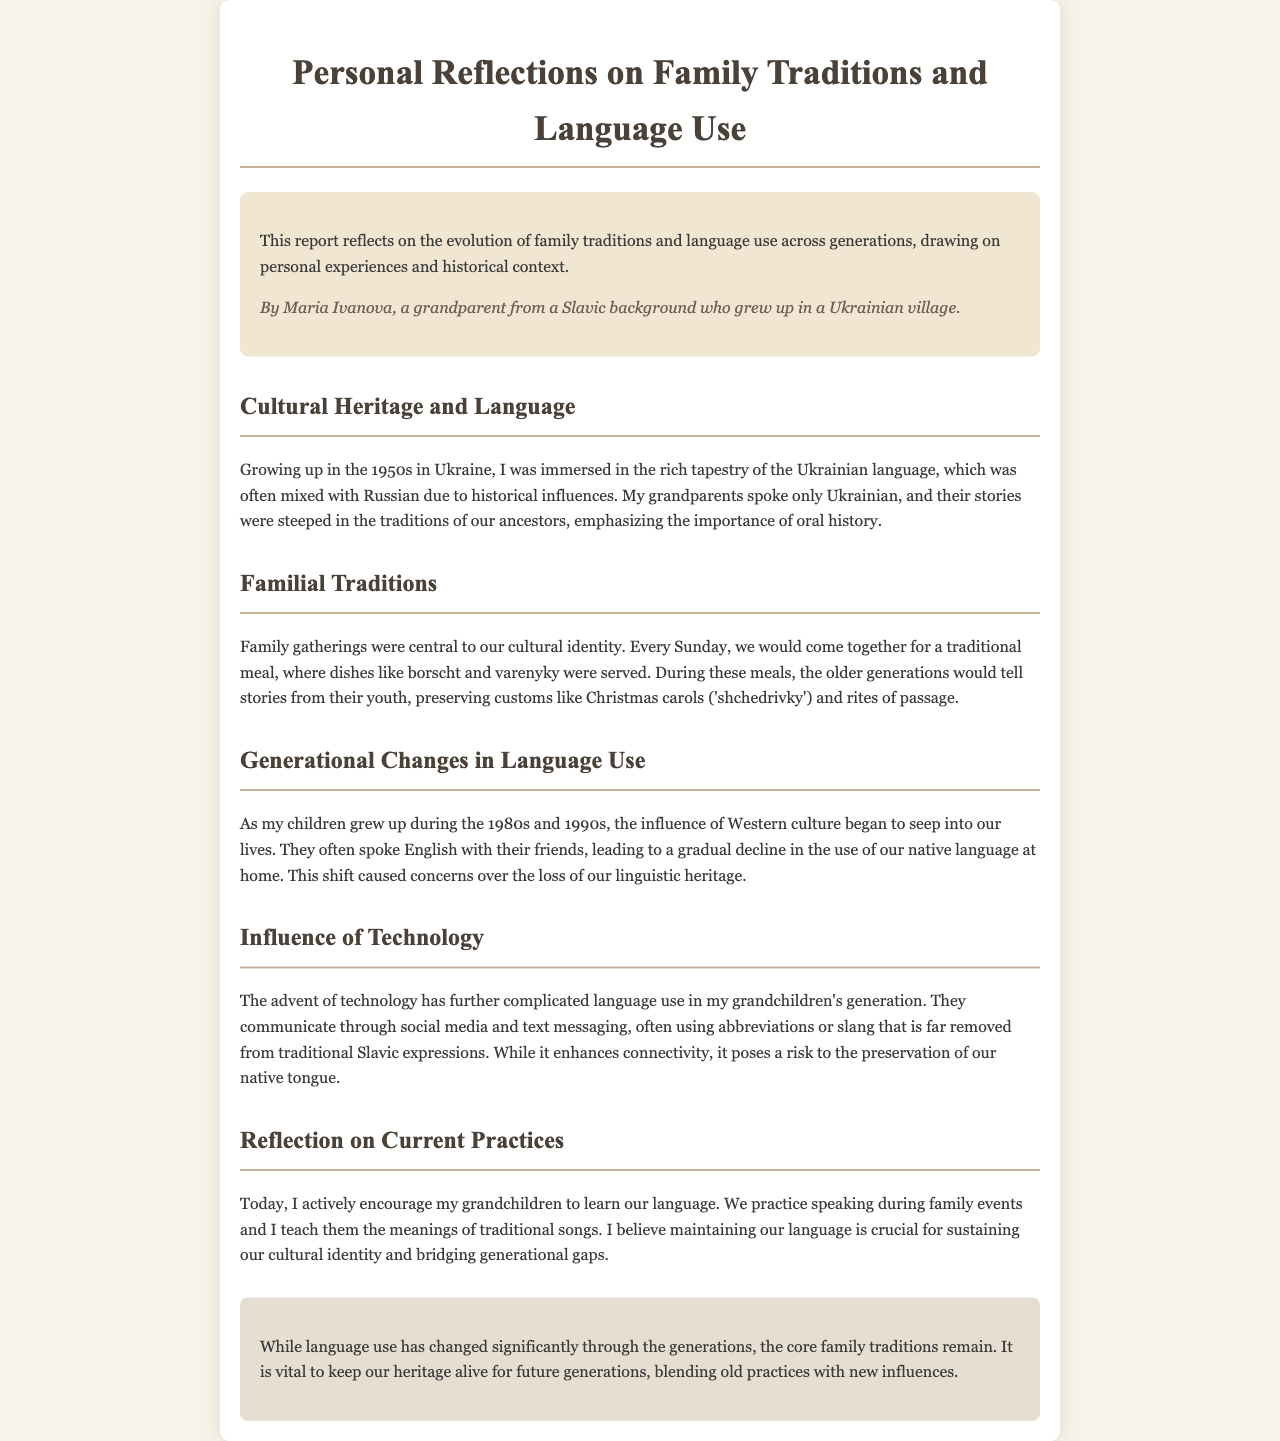What decade did the author grow up in? The author mentions growing up in the 1950s in Ukraine, indicating the decade.
Answer: 1950s What traditional dish is mentioned in family gatherings? The document mentions borscht as a traditional dish served during family gatherings.
Answer: borscht What language did the author's grandparents speak? The report states that the author's grandparents spoke only Ukrainian.
Answer: Ukrainian What was the influence on language use during the 1980s and 1990s? The author notes that the influence of Western culture caused a decline in the use of their native language at home.
Answer: Western culture What does the author encourage her grandchildren to learn? The document indicates that the author actively encourages her grandchildren to learn their native language.
Answer: their native language How does technology impact grandchildren's language use? The author highlights that technology has led to communication using slang that is far removed from traditional expressions.
Answer: slang What cultural practices does the author believe are vital to sustain? The report emphasizes sustaining cultural identity and family traditions as vital practices.
Answer: cultural identity What types of stories did the older generations tell during family meals? The older generations shared stories from their youth during family meals, preserving oral traditions.
Answer: stories from their youth 